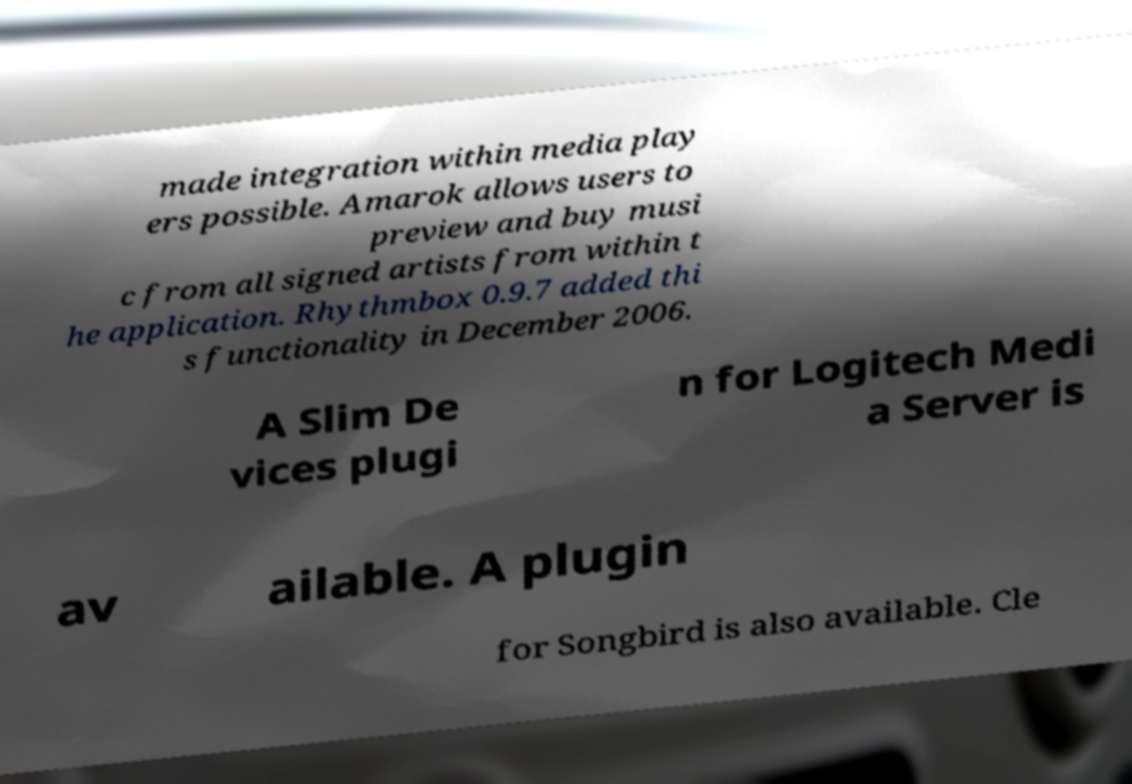Please identify and transcribe the text found in this image. made integration within media play ers possible. Amarok allows users to preview and buy musi c from all signed artists from within t he application. Rhythmbox 0.9.7 added thi s functionality in December 2006. A Slim De vices plugi n for Logitech Medi a Server is av ailable. A plugin for Songbird is also available. Cle 